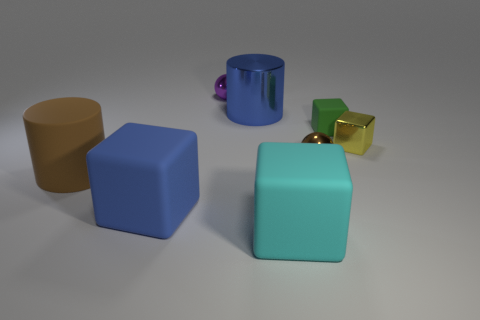Subtract all rubber cubes. How many cubes are left? 1 Subtract all cyan cubes. How many cubes are left? 3 Subtract 2 blocks. How many blocks are left? 2 Add 2 green matte things. How many objects exist? 10 Subtract all cylinders. How many objects are left? 6 Subtract all blue blocks. Subtract all purple cylinders. How many blocks are left? 3 Subtract all purple metal cylinders. Subtract all big brown matte cylinders. How many objects are left? 7 Add 4 metallic cubes. How many metallic cubes are left? 5 Add 7 large green shiny balls. How many large green shiny balls exist? 7 Subtract 0 green spheres. How many objects are left? 8 